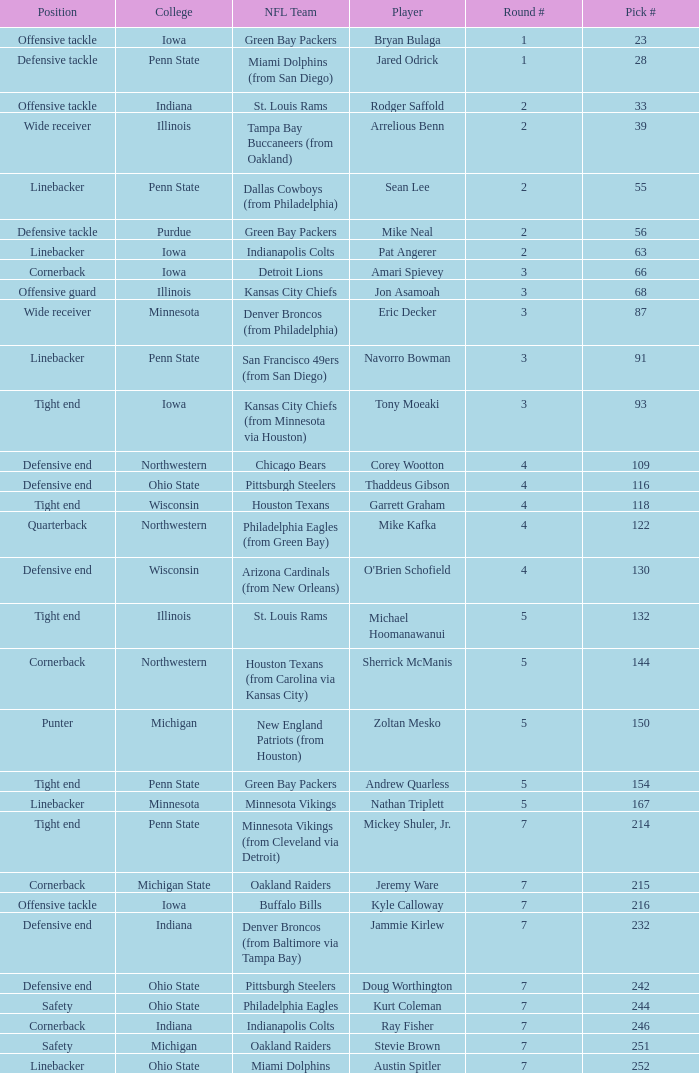What was Sherrick McManis's earliest round? 5.0. Help me parse the entirety of this table. {'header': ['Position', 'College', 'NFL Team', 'Player', 'Round #', 'Pick #'], 'rows': [['Offensive tackle', 'Iowa', 'Green Bay Packers', 'Bryan Bulaga', '1', '23'], ['Defensive tackle', 'Penn State', 'Miami Dolphins (from San Diego)', 'Jared Odrick', '1', '28'], ['Offensive tackle', 'Indiana', 'St. Louis Rams', 'Rodger Saffold', '2', '33'], ['Wide receiver', 'Illinois', 'Tampa Bay Buccaneers (from Oakland)', 'Arrelious Benn', '2', '39'], ['Linebacker', 'Penn State', 'Dallas Cowboys (from Philadelphia)', 'Sean Lee', '2', '55'], ['Defensive tackle', 'Purdue', 'Green Bay Packers', 'Mike Neal', '2', '56'], ['Linebacker', 'Iowa', 'Indianapolis Colts', 'Pat Angerer', '2', '63'], ['Cornerback', 'Iowa', 'Detroit Lions', 'Amari Spievey', '3', '66'], ['Offensive guard', 'Illinois', 'Kansas City Chiefs', 'Jon Asamoah', '3', '68'], ['Wide receiver', 'Minnesota', 'Denver Broncos (from Philadelphia)', 'Eric Decker', '3', '87'], ['Linebacker', 'Penn State', 'San Francisco 49ers (from San Diego)', 'Navorro Bowman', '3', '91'], ['Tight end', 'Iowa', 'Kansas City Chiefs (from Minnesota via Houston)', 'Tony Moeaki', '3', '93'], ['Defensive end', 'Northwestern', 'Chicago Bears', 'Corey Wootton', '4', '109'], ['Defensive end', 'Ohio State', 'Pittsburgh Steelers', 'Thaddeus Gibson', '4', '116'], ['Tight end', 'Wisconsin', 'Houston Texans', 'Garrett Graham', '4', '118'], ['Quarterback', 'Northwestern', 'Philadelphia Eagles (from Green Bay)', 'Mike Kafka', '4', '122'], ['Defensive end', 'Wisconsin', 'Arizona Cardinals (from New Orleans)', "O'Brien Schofield", '4', '130'], ['Tight end', 'Illinois', 'St. Louis Rams', 'Michael Hoomanawanui', '5', '132'], ['Cornerback', 'Northwestern', 'Houston Texans (from Carolina via Kansas City)', 'Sherrick McManis', '5', '144'], ['Punter', 'Michigan', 'New England Patriots (from Houston)', 'Zoltan Mesko', '5', '150'], ['Tight end', 'Penn State', 'Green Bay Packers', 'Andrew Quarless', '5', '154'], ['Linebacker', 'Minnesota', 'Minnesota Vikings', 'Nathan Triplett', '5', '167'], ['Tight end', 'Penn State', 'Minnesota Vikings (from Cleveland via Detroit)', 'Mickey Shuler, Jr.', '7', '214'], ['Cornerback', 'Michigan State', 'Oakland Raiders', 'Jeremy Ware', '7', '215'], ['Offensive tackle', 'Iowa', 'Buffalo Bills', 'Kyle Calloway', '7', '216'], ['Defensive end', 'Indiana', 'Denver Broncos (from Baltimore via Tampa Bay)', 'Jammie Kirlew', '7', '232'], ['Defensive end', 'Ohio State', 'Pittsburgh Steelers', 'Doug Worthington', '7', '242'], ['Safety', 'Ohio State', 'Philadelphia Eagles', 'Kurt Coleman', '7', '244'], ['Cornerback', 'Indiana', 'Indianapolis Colts', 'Ray Fisher', '7', '246'], ['Safety', 'Michigan', 'Oakland Raiders', 'Stevie Brown', '7', '251'], ['Linebacker', 'Ohio State', 'Miami Dolphins', 'Austin Spitler', '7', '252']]} 